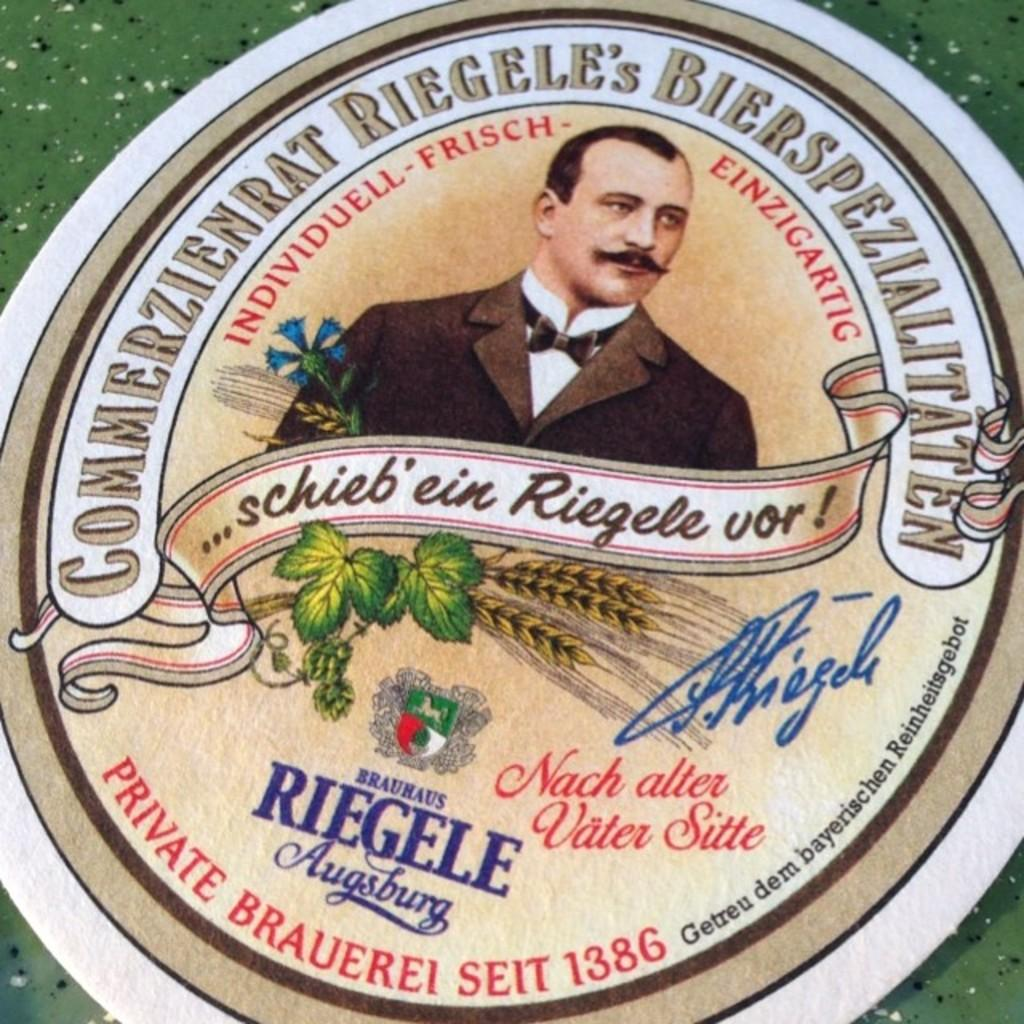What is featured in the image? There is a poster in the image. What can be seen on the poster? There is a person depicted on the poster, along with leaves. Is there any text on the poster? Yes, there is text present on the poster. How many birds are flying in the image? There are no birds present in the image. Is there a bike visible in the image? There is no bike present in the image. 